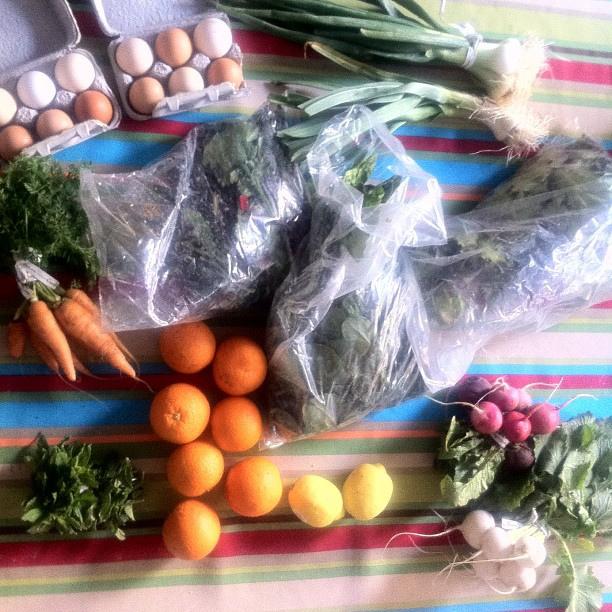Is this meat?
Quick response, please. No. Name one stripe color you see on cloth that the veggies are lying on?
Short answer required. Red. How many lemons are there?
Be succinct. 2. How many vegetables are there?
Concise answer only. 5. 